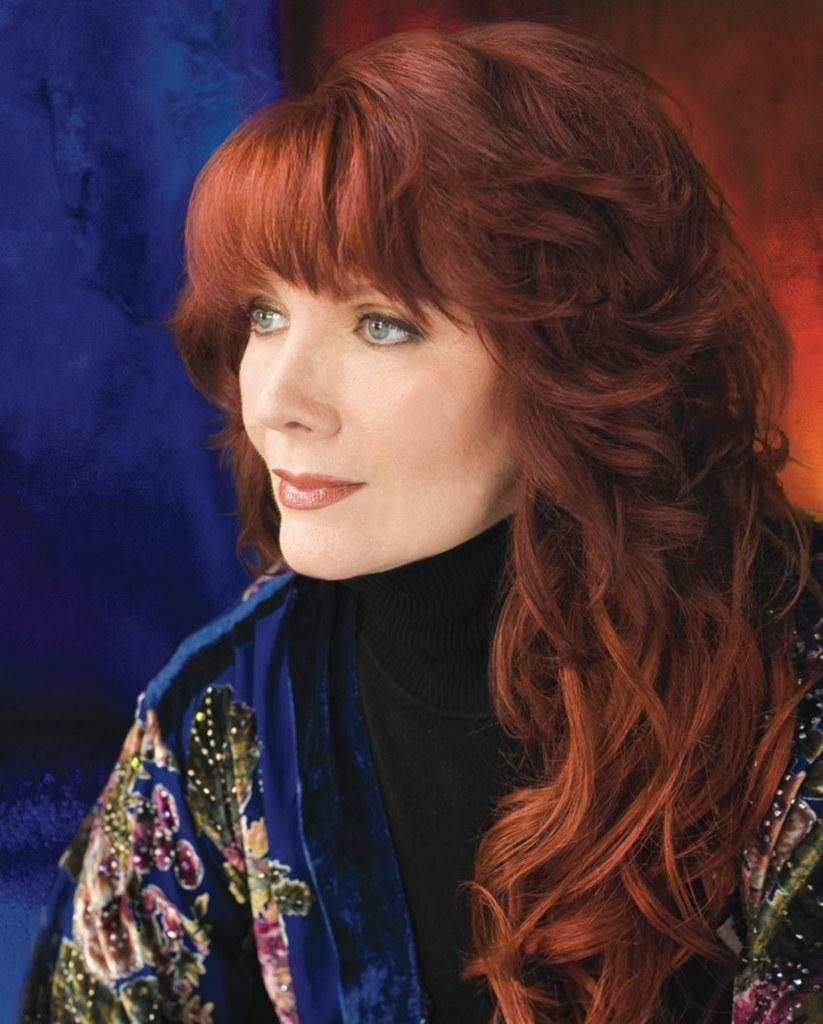Who is the main subject in the image? There is a lady in the center of the image. What is the lady wearing? The lady is wearing a blue dress. What type of whistle does the lady have in her hand in the image? There is no whistle present in the image. 